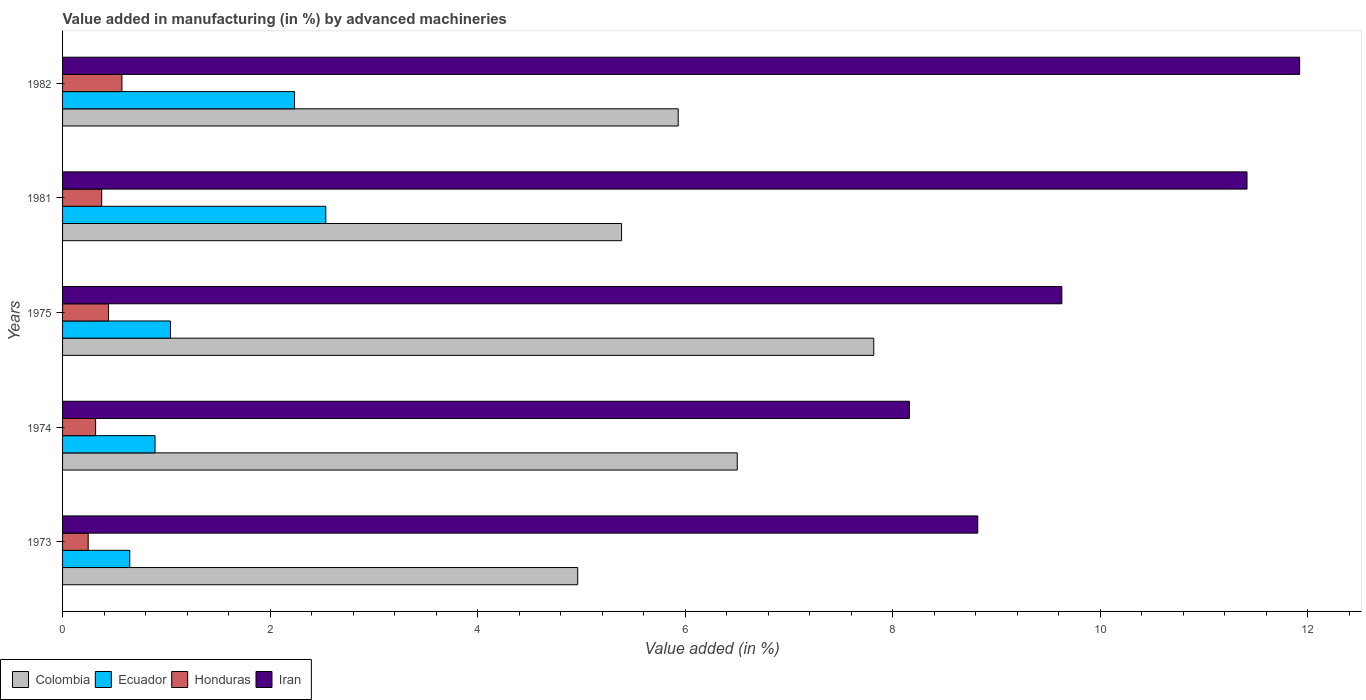Are the number of bars per tick equal to the number of legend labels?
Your answer should be compact. Yes. Are the number of bars on each tick of the Y-axis equal?
Offer a terse response. Yes. How many bars are there on the 4th tick from the top?
Provide a short and direct response. 4. In how many cases, is the number of bars for a given year not equal to the number of legend labels?
Ensure brevity in your answer.  0. What is the percentage of value added in manufacturing by advanced machineries in Iran in 1973?
Give a very brief answer. 8.82. Across all years, what is the maximum percentage of value added in manufacturing by advanced machineries in Ecuador?
Ensure brevity in your answer.  2.54. Across all years, what is the minimum percentage of value added in manufacturing by advanced machineries in Honduras?
Offer a terse response. 0.25. In which year was the percentage of value added in manufacturing by advanced machineries in Colombia maximum?
Offer a very short reply. 1975. In which year was the percentage of value added in manufacturing by advanced machineries in Iran minimum?
Provide a short and direct response. 1974. What is the total percentage of value added in manufacturing by advanced machineries in Colombia in the graph?
Provide a succinct answer. 30.61. What is the difference between the percentage of value added in manufacturing by advanced machineries in Ecuador in 1974 and that in 1981?
Offer a very short reply. -1.65. What is the difference between the percentage of value added in manufacturing by advanced machineries in Honduras in 1981 and the percentage of value added in manufacturing by advanced machineries in Ecuador in 1982?
Your response must be concise. -1.86. What is the average percentage of value added in manufacturing by advanced machineries in Colombia per year?
Make the answer very short. 6.12. In the year 1982, what is the difference between the percentage of value added in manufacturing by advanced machineries in Colombia and percentage of value added in manufacturing by advanced machineries in Ecuador?
Offer a very short reply. 3.7. What is the ratio of the percentage of value added in manufacturing by advanced machineries in Ecuador in 1975 to that in 1982?
Provide a succinct answer. 0.47. What is the difference between the highest and the second highest percentage of value added in manufacturing by advanced machineries in Ecuador?
Offer a very short reply. 0.3. What is the difference between the highest and the lowest percentage of value added in manufacturing by advanced machineries in Iran?
Offer a very short reply. 3.76. In how many years, is the percentage of value added in manufacturing by advanced machineries in Colombia greater than the average percentage of value added in manufacturing by advanced machineries in Colombia taken over all years?
Provide a short and direct response. 2. Is the sum of the percentage of value added in manufacturing by advanced machineries in Iran in 1974 and 1982 greater than the maximum percentage of value added in manufacturing by advanced machineries in Colombia across all years?
Provide a short and direct response. Yes. What does the 2nd bar from the bottom in 1974 represents?
Keep it short and to the point. Ecuador. Is it the case that in every year, the sum of the percentage of value added in manufacturing by advanced machineries in Honduras and percentage of value added in manufacturing by advanced machineries in Colombia is greater than the percentage of value added in manufacturing by advanced machineries in Iran?
Make the answer very short. No. Are all the bars in the graph horizontal?
Offer a terse response. Yes. How many years are there in the graph?
Keep it short and to the point. 5. Are the values on the major ticks of X-axis written in scientific E-notation?
Your response must be concise. No. Does the graph contain any zero values?
Ensure brevity in your answer.  No. What is the title of the graph?
Offer a very short reply. Value added in manufacturing (in %) by advanced machineries. What is the label or title of the X-axis?
Keep it short and to the point. Value added (in %). What is the label or title of the Y-axis?
Offer a very short reply. Years. What is the Value added (in %) of Colombia in 1973?
Offer a very short reply. 4.96. What is the Value added (in %) in Ecuador in 1973?
Your response must be concise. 0.65. What is the Value added (in %) of Honduras in 1973?
Your answer should be very brief. 0.25. What is the Value added (in %) of Iran in 1973?
Offer a terse response. 8.82. What is the Value added (in %) in Colombia in 1974?
Provide a succinct answer. 6.5. What is the Value added (in %) of Ecuador in 1974?
Give a very brief answer. 0.89. What is the Value added (in %) of Honduras in 1974?
Your answer should be very brief. 0.32. What is the Value added (in %) in Iran in 1974?
Your response must be concise. 8.16. What is the Value added (in %) in Colombia in 1975?
Provide a short and direct response. 7.82. What is the Value added (in %) of Ecuador in 1975?
Provide a succinct answer. 1.04. What is the Value added (in %) in Honduras in 1975?
Offer a terse response. 0.44. What is the Value added (in %) of Iran in 1975?
Ensure brevity in your answer.  9.63. What is the Value added (in %) in Colombia in 1981?
Provide a short and direct response. 5.39. What is the Value added (in %) of Ecuador in 1981?
Give a very brief answer. 2.54. What is the Value added (in %) of Honduras in 1981?
Give a very brief answer. 0.38. What is the Value added (in %) in Iran in 1981?
Your answer should be very brief. 11.42. What is the Value added (in %) of Colombia in 1982?
Offer a terse response. 5.93. What is the Value added (in %) of Ecuador in 1982?
Your answer should be compact. 2.24. What is the Value added (in %) of Honduras in 1982?
Your response must be concise. 0.57. What is the Value added (in %) of Iran in 1982?
Offer a terse response. 11.92. Across all years, what is the maximum Value added (in %) of Colombia?
Ensure brevity in your answer.  7.82. Across all years, what is the maximum Value added (in %) in Ecuador?
Keep it short and to the point. 2.54. Across all years, what is the maximum Value added (in %) in Honduras?
Provide a short and direct response. 0.57. Across all years, what is the maximum Value added (in %) in Iran?
Provide a short and direct response. 11.92. Across all years, what is the minimum Value added (in %) in Colombia?
Provide a short and direct response. 4.96. Across all years, what is the minimum Value added (in %) in Ecuador?
Offer a very short reply. 0.65. Across all years, what is the minimum Value added (in %) in Honduras?
Make the answer very short. 0.25. Across all years, what is the minimum Value added (in %) in Iran?
Offer a very short reply. 8.16. What is the total Value added (in %) of Colombia in the graph?
Offer a terse response. 30.61. What is the total Value added (in %) of Ecuador in the graph?
Give a very brief answer. 7.35. What is the total Value added (in %) in Honduras in the graph?
Keep it short and to the point. 1.96. What is the total Value added (in %) in Iran in the graph?
Your answer should be compact. 49.95. What is the difference between the Value added (in %) of Colombia in 1973 and that in 1974?
Your response must be concise. -1.54. What is the difference between the Value added (in %) of Ecuador in 1973 and that in 1974?
Your answer should be compact. -0.24. What is the difference between the Value added (in %) of Honduras in 1973 and that in 1974?
Provide a succinct answer. -0.07. What is the difference between the Value added (in %) of Iran in 1973 and that in 1974?
Your answer should be compact. 0.66. What is the difference between the Value added (in %) in Colombia in 1973 and that in 1975?
Your answer should be very brief. -2.85. What is the difference between the Value added (in %) in Ecuador in 1973 and that in 1975?
Provide a short and direct response. -0.39. What is the difference between the Value added (in %) of Honduras in 1973 and that in 1975?
Offer a terse response. -0.2. What is the difference between the Value added (in %) of Iran in 1973 and that in 1975?
Give a very brief answer. -0.81. What is the difference between the Value added (in %) of Colombia in 1973 and that in 1981?
Offer a very short reply. -0.42. What is the difference between the Value added (in %) in Ecuador in 1973 and that in 1981?
Offer a terse response. -1.89. What is the difference between the Value added (in %) in Honduras in 1973 and that in 1981?
Your answer should be very brief. -0.13. What is the difference between the Value added (in %) of Iran in 1973 and that in 1981?
Your answer should be compact. -2.59. What is the difference between the Value added (in %) of Colombia in 1973 and that in 1982?
Your answer should be compact. -0.97. What is the difference between the Value added (in %) in Ecuador in 1973 and that in 1982?
Provide a short and direct response. -1.59. What is the difference between the Value added (in %) of Honduras in 1973 and that in 1982?
Keep it short and to the point. -0.33. What is the difference between the Value added (in %) in Iran in 1973 and that in 1982?
Your response must be concise. -3.1. What is the difference between the Value added (in %) in Colombia in 1974 and that in 1975?
Keep it short and to the point. -1.32. What is the difference between the Value added (in %) of Ecuador in 1974 and that in 1975?
Provide a short and direct response. -0.15. What is the difference between the Value added (in %) of Honduras in 1974 and that in 1975?
Keep it short and to the point. -0.12. What is the difference between the Value added (in %) in Iran in 1974 and that in 1975?
Ensure brevity in your answer.  -1.47. What is the difference between the Value added (in %) of Colombia in 1974 and that in 1981?
Ensure brevity in your answer.  1.11. What is the difference between the Value added (in %) of Ecuador in 1974 and that in 1981?
Give a very brief answer. -1.65. What is the difference between the Value added (in %) of Honduras in 1974 and that in 1981?
Give a very brief answer. -0.06. What is the difference between the Value added (in %) in Iran in 1974 and that in 1981?
Keep it short and to the point. -3.25. What is the difference between the Value added (in %) in Colombia in 1974 and that in 1982?
Your answer should be compact. 0.57. What is the difference between the Value added (in %) of Ecuador in 1974 and that in 1982?
Provide a short and direct response. -1.34. What is the difference between the Value added (in %) in Honduras in 1974 and that in 1982?
Your answer should be compact. -0.25. What is the difference between the Value added (in %) in Iran in 1974 and that in 1982?
Provide a short and direct response. -3.76. What is the difference between the Value added (in %) of Colombia in 1975 and that in 1981?
Ensure brevity in your answer.  2.43. What is the difference between the Value added (in %) in Ecuador in 1975 and that in 1981?
Give a very brief answer. -1.5. What is the difference between the Value added (in %) of Honduras in 1975 and that in 1981?
Your response must be concise. 0.07. What is the difference between the Value added (in %) in Iran in 1975 and that in 1981?
Give a very brief answer. -1.78. What is the difference between the Value added (in %) of Colombia in 1975 and that in 1982?
Your response must be concise. 1.88. What is the difference between the Value added (in %) of Ecuador in 1975 and that in 1982?
Offer a very short reply. -1.2. What is the difference between the Value added (in %) in Honduras in 1975 and that in 1982?
Make the answer very short. -0.13. What is the difference between the Value added (in %) in Iran in 1975 and that in 1982?
Make the answer very short. -2.29. What is the difference between the Value added (in %) in Colombia in 1981 and that in 1982?
Ensure brevity in your answer.  -0.55. What is the difference between the Value added (in %) in Ecuador in 1981 and that in 1982?
Offer a terse response. 0.3. What is the difference between the Value added (in %) in Honduras in 1981 and that in 1982?
Your answer should be very brief. -0.19. What is the difference between the Value added (in %) in Iran in 1981 and that in 1982?
Ensure brevity in your answer.  -0.51. What is the difference between the Value added (in %) of Colombia in 1973 and the Value added (in %) of Ecuador in 1974?
Your answer should be very brief. 4.07. What is the difference between the Value added (in %) of Colombia in 1973 and the Value added (in %) of Honduras in 1974?
Keep it short and to the point. 4.65. What is the difference between the Value added (in %) of Colombia in 1973 and the Value added (in %) of Iran in 1974?
Offer a very short reply. -3.2. What is the difference between the Value added (in %) of Ecuador in 1973 and the Value added (in %) of Honduras in 1974?
Give a very brief answer. 0.33. What is the difference between the Value added (in %) of Ecuador in 1973 and the Value added (in %) of Iran in 1974?
Make the answer very short. -7.51. What is the difference between the Value added (in %) in Honduras in 1973 and the Value added (in %) in Iran in 1974?
Keep it short and to the point. -7.91. What is the difference between the Value added (in %) of Colombia in 1973 and the Value added (in %) of Ecuador in 1975?
Offer a very short reply. 3.92. What is the difference between the Value added (in %) in Colombia in 1973 and the Value added (in %) in Honduras in 1975?
Give a very brief answer. 4.52. What is the difference between the Value added (in %) of Colombia in 1973 and the Value added (in %) of Iran in 1975?
Give a very brief answer. -4.67. What is the difference between the Value added (in %) of Ecuador in 1973 and the Value added (in %) of Honduras in 1975?
Your response must be concise. 0.2. What is the difference between the Value added (in %) of Ecuador in 1973 and the Value added (in %) of Iran in 1975?
Give a very brief answer. -8.98. What is the difference between the Value added (in %) in Honduras in 1973 and the Value added (in %) in Iran in 1975?
Offer a very short reply. -9.38. What is the difference between the Value added (in %) in Colombia in 1973 and the Value added (in %) in Ecuador in 1981?
Ensure brevity in your answer.  2.43. What is the difference between the Value added (in %) in Colombia in 1973 and the Value added (in %) in Honduras in 1981?
Offer a very short reply. 4.59. What is the difference between the Value added (in %) of Colombia in 1973 and the Value added (in %) of Iran in 1981?
Make the answer very short. -6.45. What is the difference between the Value added (in %) in Ecuador in 1973 and the Value added (in %) in Honduras in 1981?
Give a very brief answer. 0.27. What is the difference between the Value added (in %) in Ecuador in 1973 and the Value added (in %) in Iran in 1981?
Provide a succinct answer. -10.77. What is the difference between the Value added (in %) of Honduras in 1973 and the Value added (in %) of Iran in 1981?
Give a very brief answer. -11.17. What is the difference between the Value added (in %) of Colombia in 1973 and the Value added (in %) of Ecuador in 1982?
Offer a very short reply. 2.73. What is the difference between the Value added (in %) of Colombia in 1973 and the Value added (in %) of Honduras in 1982?
Ensure brevity in your answer.  4.39. What is the difference between the Value added (in %) of Colombia in 1973 and the Value added (in %) of Iran in 1982?
Your response must be concise. -6.96. What is the difference between the Value added (in %) in Ecuador in 1973 and the Value added (in %) in Honduras in 1982?
Make the answer very short. 0.08. What is the difference between the Value added (in %) in Ecuador in 1973 and the Value added (in %) in Iran in 1982?
Your response must be concise. -11.27. What is the difference between the Value added (in %) of Honduras in 1973 and the Value added (in %) of Iran in 1982?
Your response must be concise. -11.68. What is the difference between the Value added (in %) in Colombia in 1974 and the Value added (in %) in Ecuador in 1975?
Make the answer very short. 5.46. What is the difference between the Value added (in %) in Colombia in 1974 and the Value added (in %) in Honduras in 1975?
Give a very brief answer. 6.06. What is the difference between the Value added (in %) of Colombia in 1974 and the Value added (in %) of Iran in 1975?
Your response must be concise. -3.13. What is the difference between the Value added (in %) of Ecuador in 1974 and the Value added (in %) of Honduras in 1975?
Make the answer very short. 0.45. What is the difference between the Value added (in %) of Ecuador in 1974 and the Value added (in %) of Iran in 1975?
Provide a succinct answer. -8.74. What is the difference between the Value added (in %) of Honduras in 1974 and the Value added (in %) of Iran in 1975?
Keep it short and to the point. -9.31. What is the difference between the Value added (in %) of Colombia in 1974 and the Value added (in %) of Ecuador in 1981?
Provide a succinct answer. 3.97. What is the difference between the Value added (in %) in Colombia in 1974 and the Value added (in %) in Honduras in 1981?
Keep it short and to the point. 6.13. What is the difference between the Value added (in %) of Colombia in 1974 and the Value added (in %) of Iran in 1981?
Your response must be concise. -4.91. What is the difference between the Value added (in %) in Ecuador in 1974 and the Value added (in %) in Honduras in 1981?
Your response must be concise. 0.51. What is the difference between the Value added (in %) of Ecuador in 1974 and the Value added (in %) of Iran in 1981?
Provide a succinct answer. -10.52. What is the difference between the Value added (in %) of Honduras in 1974 and the Value added (in %) of Iran in 1981?
Keep it short and to the point. -11.1. What is the difference between the Value added (in %) of Colombia in 1974 and the Value added (in %) of Ecuador in 1982?
Your answer should be compact. 4.27. What is the difference between the Value added (in %) of Colombia in 1974 and the Value added (in %) of Honduras in 1982?
Offer a very short reply. 5.93. What is the difference between the Value added (in %) in Colombia in 1974 and the Value added (in %) in Iran in 1982?
Your answer should be compact. -5.42. What is the difference between the Value added (in %) of Ecuador in 1974 and the Value added (in %) of Honduras in 1982?
Your answer should be compact. 0.32. What is the difference between the Value added (in %) of Ecuador in 1974 and the Value added (in %) of Iran in 1982?
Provide a succinct answer. -11.03. What is the difference between the Value added (in %) in Honduras in 1974 and the Value added (in %) in Iran in 1982?
Make the answer very short. -11.6. What is the difference between the Value added (in %) in Colombia in 1975 and the Value added (in %) in Ecuador in 1981?
Keep it short and to the point. 5.28. What is the difference between the Value added (in %) in Colombia in 1975 and the Value added (in %) in Honduras in 1981?
Ensure brevity in your answer.  7.44. What is the difference between the Value added (in %) in Colombia in 1975 and the Value added (in %) in Iran in 1981?
Give a very brief answer. -3.6. What is the difference between the Value added (in %) in Ecuador in 1975 and the Value added (in %) in Honduras in 1981?
Make the answer very short. 0.66. What is the difference between the Value added (in %) in Ecuador in 1975 and the Value added (in %) in Iran in 1981?
Make the answer very short. -10.38. What is the difference between the Value added (in %) in Honduras in 1975 and the Value added (in %) in Iran in 1981?
Ensure brevity in your answer.  -10.97. What is the difference between the Value added (in %) in Colombia in 1975 and the Value added (in %) in Ecuador in 1982?
Your answer should be compact. 5.58. What is the difference between the Value added (in %) of Colombia in 1975 and the Value added (in %) of Honduras in 1982?
Your answer should be very brief. 7.25. What is the difference between the Value added (in %) in Colombia in 1975 and the Value added (in %) in Iran in 1982?
Provide a succinct answer. -4.1. What is the difference between the Value added (in %) in Ecuador in 1975 and the Value added (in %) in Honduras in 1982?
Give a very brief answer. 0.47. What is the difference between the Value added (in %) in Ecuador in 1975 and the Value added (in %) in Iran in 1982?
Your answer should be very brief. -10.88. What is the difference between the Value added (in %) in Honduras in 1975 and the Value added (in %) in Iran in 1982?
Ensure brevity in your answer.  -11.48. What is the difference between the Value added (in %) of Colombia in 1981 and the Value added (in %) of Ecuador in 1982?
Give a very brief answer. 3.15. What is the difference between the Value added (in %) of Colombia in 1981 and the Value added (in %) of Honduras in 1982?
Keep it short and to the point. 4.82. What is the difference between the Value added (in %) of Colombia in 1981 and the Value added (in %) of Iran in 1982?
Provide a short and direct response. -6.53. What is the difference between the Value added (in %) of Ecuador in 1981 and the Value added (in %) of Honduras in 1982?
Provide a succinct answer. 1.96. What is the difference between the Value added (in %) in Ecuador in 1981 and the Value added (in %) in Iran in 1982?
Keep it short and to the point. -9.39. What is the difference between the Value added (in %) in Honduras in 1981 and the Value added (in %) in Iran in 1982?
Provide a succinct answer. -11.55. What is the average Value added (in %) in Colombia per year?
Provide a short and direct response. 6.12. What is the average Value added (in %) of Ecuador per year?
Your response must be concise. 1.47. What is the average Value added (in %) of Honduras per year?
Your answer should be very brief. 0.39. What is the average Value added (in %) of Iran per year?
Provide a succinct answer. 9.99. In the year 1973, what is the difference between the Value added (in %) of Colombia and Value added (in %) of Ecuador?
Give a very brief answer. 4.32. In the year 1973, what is the difference between the Value added (in %) of Colombia and Value added (in %) of Honduras?
Give a very brief answer. 4.72. In the year 1973, what is the difference between the Value added (in %) in Colombia and Value added (in %) in Iran?
Your answer should be compact. -3.86. In the year 1973, what is the difference between the Value added (in %) in Ecuador and Value added (in %) in Honduras?
Ensure brevity in your answer.  0.4. In the year 1973, what is the difference between the Value added (in %) of Ecuador and Value added (in %) of Iran?
Your answer should be very brief. -8.17. In the year 1973, what is the difference between the Value added (in %) of Honduras and Value added (in %) of Iran?
Offer a terse response. -8.57. In the year 1974, what is the difference between the Value added (in %) in Colombia and Value added (in %) in Ecuador?
Your response must be concise. 5.61. In the year 1974, what is the difference between the Value added (in %) of Colombia and Value added (in %) of Honduras?
Give a very brief answer. 6.18. In the year 1974, what is the difference between the Value added (in %) in Colombia and Value added (in %) in Iran?
Provide a succinct answer. -1.66. In the year 1974, what is the difference between the Value added (in %) in Ecuador and Value added (in %) in Honduras?
Offer a very short reply. 0.57. In the year 1974, what is the difference between the Value added (in %) of Ecuador and Value added (in %) of Iran?
Give a very brief answer. -7.27. In the year 1974, what is the difference between the Value added (in %) in Honduras and Value added (in %) in Iran?
Your response must be concise. -7.84. In the year 1975, what is the difference between the Value added (in %) in Colombia and Value added (in %) in Ecuador?
Keep it short and to the point. 6.78. In the year 1975, what is the difference between the Value added (in %) in Colombia and Value added (in %) in Honduras?
Provide a short and direct response. 7.37. In the year 1975, what is the difference between the Value added (in %) in Colombia and Value added (in %) in Iran?
Your answer should be compact. -1.81. In the year 1975, what is the difference between the Value added (in %) of Ecuador and Value added (in %) of Honduras?
Provide a succinct answer. 0.6. In the year 1975, what is the difference between the Value added (in %) in Ecuador and Value added (in %) in Iran?
Provide a short and direct response. -8.59. In the year 1975, what is the difference between the Value added (in %) of Honduras and Value added (in %) of Iran?
Make the answer very short. -9.19. In the year 1981, what is the difference between the Value added (in %) in Colombia and Value added (in %) in Ecuador?
Offer a terse response. 2.85. In the year 1981, what is the difference between the Value added (in %) of Colombia and Value added (in %) of Honduras?
Your answer should be compact. 5.01. In the year 1981, what is the difference between the Value added (in %) of Colombia and Value added (in %) of Iran?
Provide a succinct answer. -6.03. In the year 1981, what is the difference between the Value added (in %) in Ecuador and Value added (in %) in Honduras?
Give a very brief answer. 2.16. In the year 1981, what is the difference between the Value added (in %) in Ecuador and Value added (in %) in Iran?
Your answer should be very brief. -8.88. In the year 1981, what is the difference between the Value added (in %) in Honduras and Value added (in %) in Iran?
Your response must be concise. -11.04. In the year 1982, what is the difference between the Value added (in %) of Colombia and Value added (in %) of Ecuador?
Your answer should be compact. 3.7. In the year 1982, what is the difference between the Value added (in %) of Colombia and Value added (in %) of Honduras?
Your answer should be very brief. 5.36. In the year 1982, what is the difference between the Value added (in %) of Colombia and Value added (in %) of Iran?
Give a very brief answer. -5.99. In the year 1982, what is the difference between the Value added (in %) in Ecuador and Value added (in %) in Honduras?
Keep it short and to the point. 1.66. In the year 1982, what is the difference between the Value added (in %) of Ecuador and Value added (in %) of Iran?
Ensure brevity in your answer.  -9.69. In the year 1982, what is the difference between the Value added (in %) in Honduras and Value added (in %) in Iran?
Your answer should be very brief. -11.35. What is the ratio of the Value added (in %) in Colombia in 1973 to that in 1974?
Offer a very short reply. 0.76. What is the ratio of the Value added (in %) in Ecuador in 1973 to that in 1974?
Your answer should be compact. 0.73. What is the ratio of the Value added (in %) of Honduras in 1973 to that in 1974?
Make the answer very short. 0.78. What is the ratio of the Value added (in %) of Iran in 1973 to that in 1974?
Provide a short and direct response. 1.08. What is the ratio of the Value added (in %) in Colombia in 1973 to that in 1975?
Offer a terse response. 0.64. What is the ratio of the Value added (in %) in Ecuador in 1973 to that in 1975?
Offer a very short reply. 0.62. What is the ratio of the Value added (in %) of Honduras in 1973 to that in 1975?
Offer a terse response. 0.56. What is the ratio of the Value added (in %) in Iran in 1973 to that in 1975?
Make the answer very short. 0.92. What is the ratio of the Value added (in %) in Colombia in 1973 to that in 1981?
Keep it short and to the point. 0.92. What is the ratio of the Value added (in %) in Ecuador in 1973 to that in 1981?
Your answer should be very brief. 0.26. What is the ratio of the Value added (in %) in Honduras in 1973 to that in 1981?
Offer a very short reply. 0.65. What is the ratio of the Value added (in %) in Iran in 1973 to that in 1981?
Offer a terse response. 0.77. What is the ratio of the Value added (in %) in Colombia in 1973 to that in 1982?
Your response must be concise. 0.84. What is the ratio of the Value added (in %) of Ecuador in 1973 to that in 1982?
Your response must be concise. 0.29. What is the ratio of the Value added (in %) of Honduras in 1973 to that in 1982?
Ensure brevity in your answer.  0.43. What is the ratio of the Value added (in %) in Iran in 1973 to that in 1982?
Offer a terse response. 0.74. What is the ratio of the Value added (in %) of Colombia in 1974 to that in 1975?
Your response must be concise. 0.83. What is the ratio of the Value added (in %) of Ecuador in 1974 to that in 1975?
Keep it short and to the point. 0.86. What is the ratio of the Value added (in %) in Honduras in 1974 to that in 1975?
Provide a succinct answer. 0.72. What is the ratio of the Value added (in %) of Iran in 1974 to that in 1975?
Your response must be concise. 0.85. What is the ratio of the Value added (in %) of Colombia in 1974 to that in 1981?
Provide a succinct answer. 1.21. What is the ratio of the Value added (in %) in Ecuador in 1974 to that in 1981?
Keep it short and to the point. 0.35. What is the ratio of the Value added (in %) in Honduras in 1974 to that in 1981?
Give a very brief answer. 0.84. What is the ratio of the Value added (in %) of Iran in 1974 to that in 1981?
Provide a short and direct response. 0.71. What is the ratio of the Value added (in %) in Colombia in 1974 to that in 1982?
Offer a terse response. 1.1. What is the ratio of the Value added (in %) in Ecuador in 1974 to that in 1982?
Your response must be concise. 0.4. What is the ratio of the Value added (in %) in Honduras in 1974 to that in 1982?
Your answer should be compact. 0.56. What is the ratio of the Value added (in %) of Iran in 1974 to that in 1982?
Provide a short and direct response. 0.68. What is the ratio of the Value added (in %) in Colombia in 1975 to that in 1981?
Your answer should be very brief. 1.45. What is the ratio of the Value added (in %) in Ecuador in 1975 to that in 1981?
Your answer should be compact. 0.41. What is the ratio of the Value added (in %) of Honduras in 1975 to that in 1981?
Ensure brevity in your answer.  1.17. What is the ratio of the Value added (in %) in Iran in 1975 to that in 1981?
Your response must be concise. 0.84. What is the ratio of the Value added (in %) in Colombia in 1975 to that in 1982?
Offer a terse response. 1.32. What is the ratio of the Value added (in %) of Ecuador in 1975 to that in 1982?
Offer a terse response. 0.47. What is the ratio of the Value added (in %) of Honduras in 1975 to that in 1982?
Offer a very short reply. 0.77. What is the ratio of the Value added (in %) of Iran in 1975 to that in 1982?
Offer a very short reply. 0.81. What is the ratio of the Value added (in %) of Colombia in 1981 to that in 1982?
Keep it short and to the point. 0.91. What is the ratio of the Value added (in %) in Ecuador in 1981 to that in 1982?
Make the answer very short. 1.13. What is the ratio of the Value added (in %) in Honduras in 1981 to that in 1982?
Offer a terse response. 0.66. What is the ratio of the Value added (in %) of Iran in 1981 to that in 1982?
Make the answer very short. 0.96. What is the difference between the highest and the second highest Value added (in %) of Colombia?
Give a very brief answer. 1.32. What is the difference between the highest and the second highest Value added (in %) of Ecuador?
Provide a succinct answer. 0.3. What is the difference between the highest and the second highest Value added (in %) of Honduras?
Your answer should be compact. 0.13. What is the difference between the highest and the second highest Value added (in %) in Iran?
Your answer should be compact. 0.51. What is the difference between the highest and the lowest Value added (in %) in Colombia?
Make the answer very short. 2.85. What is the difference between the highest and the lowest Value added (in %) in Ecuador?
Ensure brevity in your answer.  1.89. What is the difference between the highest and the lowest Value added (in %) of Honduras?
Provide a short and direct response. 0.33. What is the difference between the highest and the lowest Value added (in %) in Iran?
Your answer should be compact. 3.76. 